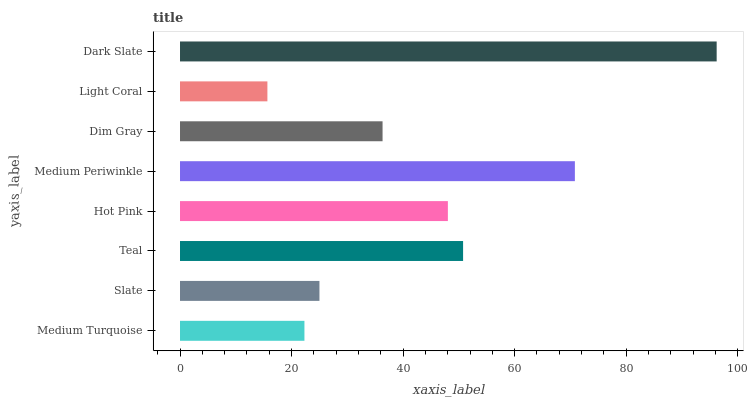Is Light Coral the minimum?
Answer yes or no. Yes. Is Dark Slate the maximum?
Answer yes or no. Yes. Is Slate the minimum?
Answer yes or no. No. Is Slate the maximum?
Answer yes or no. No. Is Slate greater than Medium Turquoise?
Answer yes or no. Yes. Is Medium Turquoise less than Slate?
Answer yes or no. Yes. Is Medium Turquoise greater than Slate?
Answer yes or no. No. Is Slate less than Medium Turquoise?
Answer yes or no. No. Is Hot Pink the high median?
Answer yes or no. Yes. Is Dim Gray the low median?
Answer yes or no. Yes. Is Teal the high median?
Answer yes or no. No. Is Light Coral the low median?
Answer yes or no. No. 